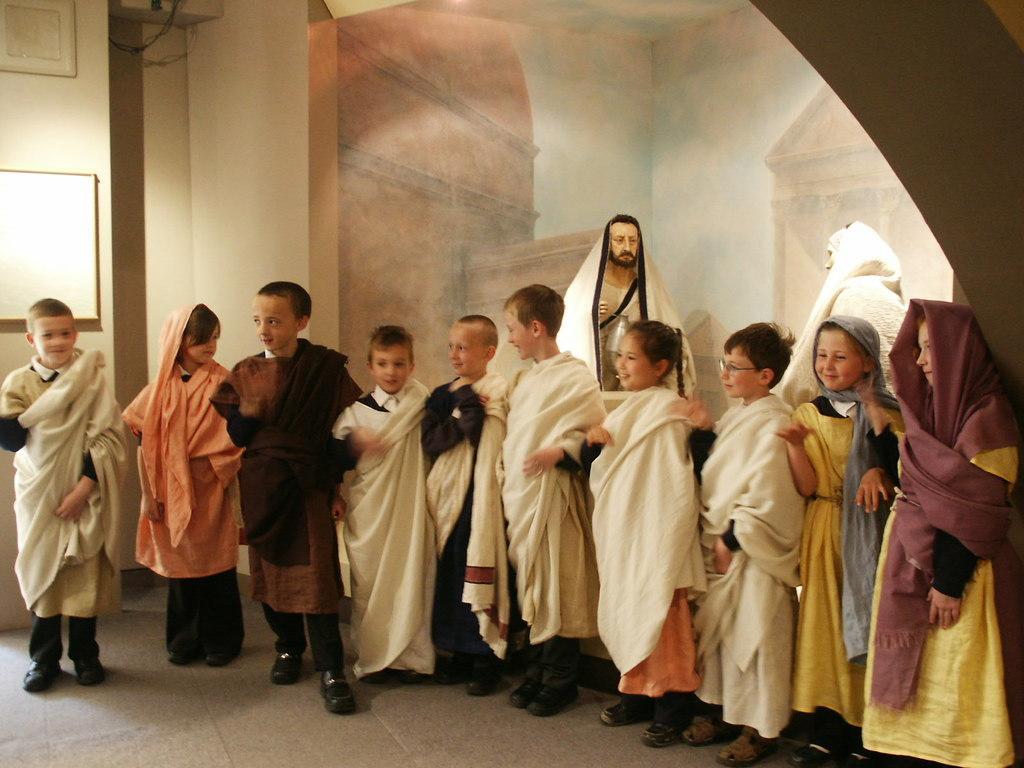Please provide a concise description of this image. There are group of children standing and smiling. They wore the fancy dresses. These are the sculptures. I can see the wall painting in the background. This looks like a board, which is attached to the wall. 